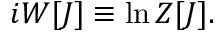<formula> <loc_0><loc_0><loc_500><loc_500>i W [ J ] \equiv \ln Z [ J ] .</formula> 